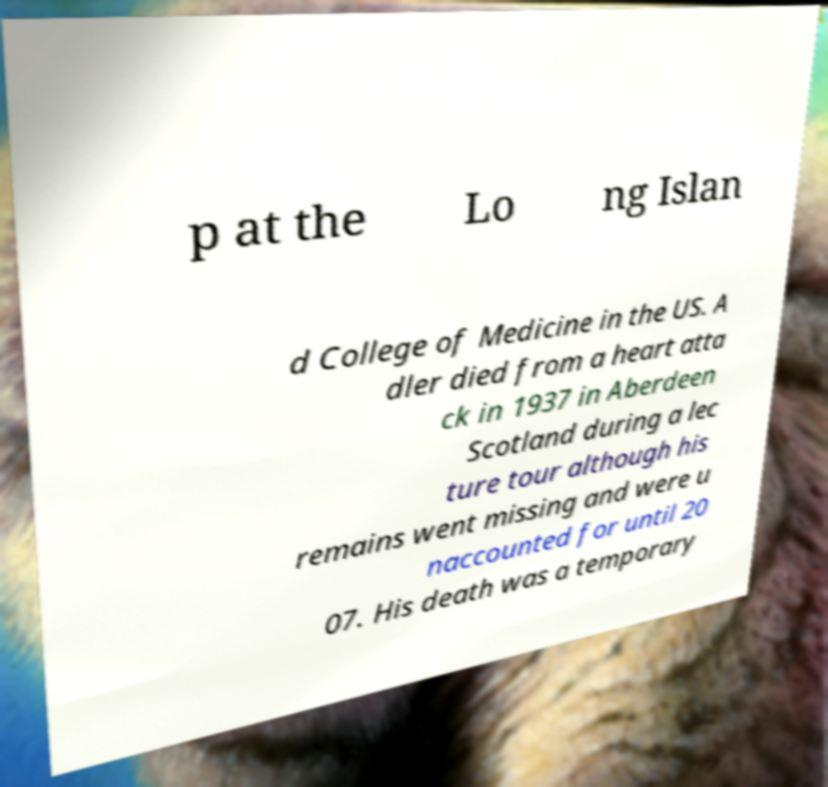Could you assist in decoding the text presented in this image and type it out clearly? p at the Lo ng Islan d College of Medicine in the US. A dler died from a heart atta ck in 1937 in Aberdeen Scotland during a lec ture tour although his remains went missing and were u naccounted for until 20 07. His death was a temporary 